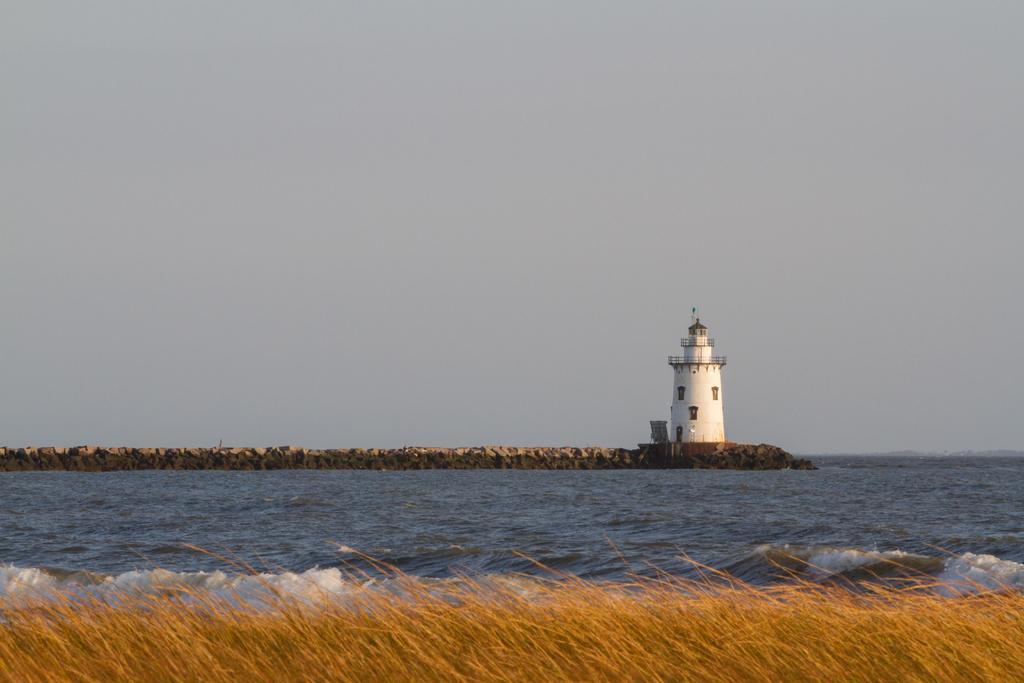Can you describe this image briefly? In this image at the bottom there is grass and in the center there is a river, in the background there is one tower and a wall. At the top of the image there is sky. 